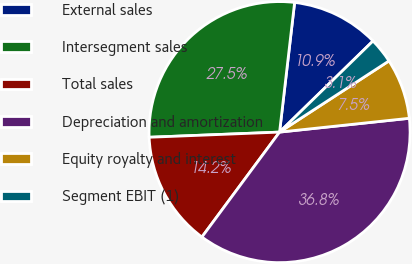Convert chart. <chart><loc_0><loc_0><loc_500><loc_500><pie_chart><fcel>External sales<fcel>Intersegment sales<fcel>Total sales<fcel>Depreciation and amortization<fcel>Equity royalty and interest<fcel>Segment EBIT (1)<nl><fcel>10.86%<fcel>27.47%<fcel>14.23%<fcel>36.83%<fcel>7.49%<fcel>3.12%<nl></chart> 